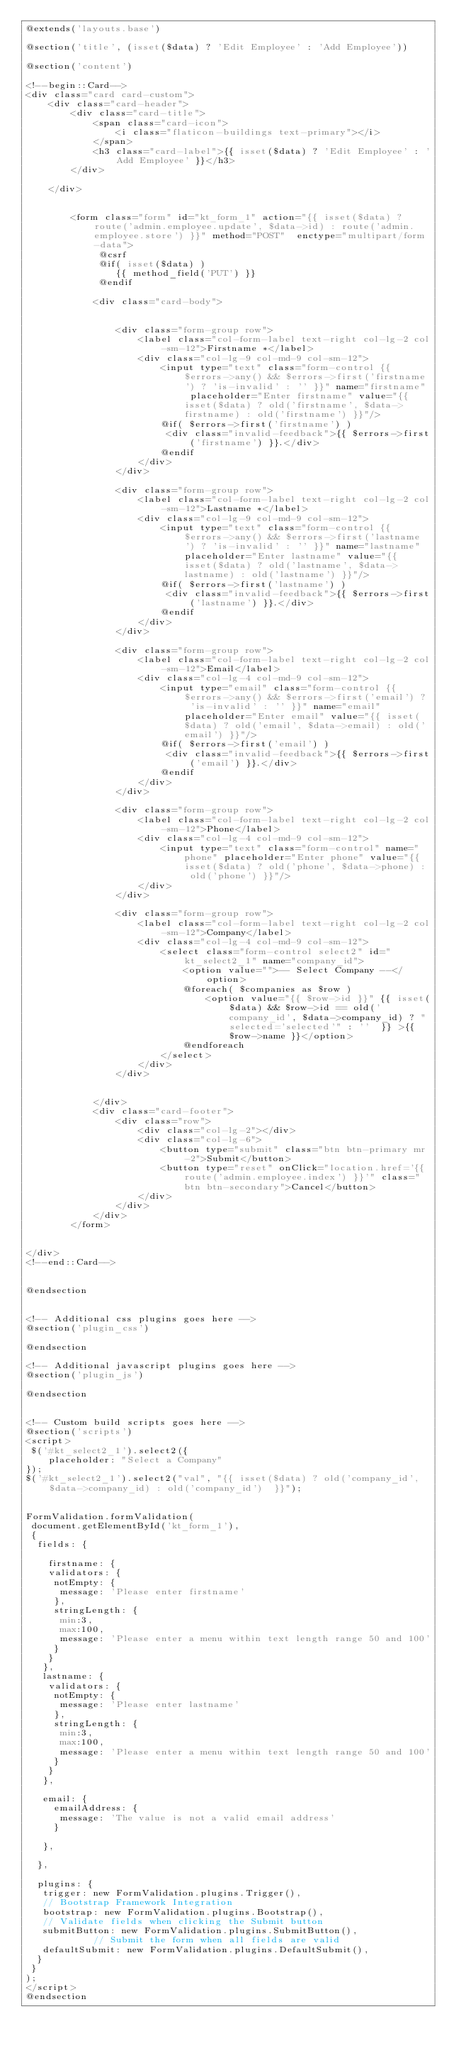<code> <loc_0><loc_0><loc_500><loc_500><_PHP_>@extends('layouts.base')

@section('title', (isset($data) ? 'Edit Employee' : 'Add Employee'))

@section('content')
    
<!--begin::Card-->
<div class="card card-custom">
    <div class="card-header">
        <div class="card-title">
            <span class="card-icon">
                <i class="flaticon-buildings text-primary"></i>
            </span>
            <h3 class="card-label">{{ isset($data) ? 'Edit Employee' : 'Add Employee' }}</h3>
        </div>

    </div>


        <form class="form" id="kt_form_1" action="{{ isset($data) ?  route('admin.employee.update', $data->id) : route('admin.employee.store') }}" method="POST"  enctype="multipart/form-data">
             @csrf
             @if( isset($data) )
                {{ method_field('PUT') }}
             @endif

            <div class="card-body">


                <div class="form-group row">
                    <label class="col-form-label text-right col-lg-2 col-sm-12">Firstname *</label>
                    <div class="col-lg-9 col-md-9 col-sm-12">
                        <input type="text" class="form-control {{ $errors->any() && $errors->first('firstname') ? 'is-invalid' : '' }}" name="firstname" placeholder="Enter firstname" value="{{ isset($data) ? old('firstname', $data->firstname) : old('firstname') }}"/>
                        @if( $errors->first('firstname') )
                         <div class="invalid-feedback">{{ $errors->first('firstname') }}.</div>
                        @endif
                    </div>
                </div>

                <div class="form-group row">
                    <label class="col-form-label text-right col-lg-2 col-sm-12">Lastname *</label>
                    <div class="col-lg-9 col-md-9 col-sm-12">
                        <input type="text" class="form-control {{ $errors->any() && $errors->first('lastname') ? 'is-invalid' : '' }}" name="lastname" placeholder="Enter lastname" value="{{ isset($data) ? old('lastname', $data->lastname) : old('lastname') }}"/>
                        @if( $errors->first('lastname') )
                         <div class="invalid-feedback">{{ $errors->first('lastname') }}.</div>
                        @endif
                    </div>
                </div>

                <div class="form-group row">
                    <label class="col-form-label text-right col-lg-2 col-sm-12">Email</label>
                    <div class="col-lg-4 col-md-9 col-sm-12">
                        <input type="email" class="form-control {{ $errors->any() && $errors->first('email') ? 'is-invalid' : '' }}" name="email" placeholder="Enter email" value="{{ isset($data) ? old('email', $data->email) : old('email') }}"/>
                        @if( $errors->first('email') )
                         <div class="invalid-feedback">{{ $errors->first('email') }}.</div>
                        @endif
                    </div>
                </div>

                <div class="form-group row">
                    <label class="col-form-label text-right col-lg-2 col-sm-12">Phone</label>
                    <div class="col-lg-4 col-md-9 col-sm-12">
                        <input type="text" class="form-control" name="phone" placeholder="Enter phone" value="{{ isset($data) ? old('phone', $data->phone) : old('phone') }}"/>
                    </div>
                </div>
                
                <div class="form-group row">
                    <label class="col-form-label text-right col-lg-2 col-sm-12">Company</label>
                    <div class="col-lg-4 col-md-9 col-sm-12">
                        <select class="form-control select2" id="kt_select2_1" name="company_id">
                            <option value="">-- Select Company --</option>
                            @foreach( $companies as $row )
                                <option value="{{ $row->id }}" {{ isset($data) && $row->id == old('company_id', $data->company_id) ? "selected='selected'" : ''  }} >{{ $row->name }}</option>
                            @endforeach
                        </select>
                    </div>
                </div>

        
            </div>
            <div class="card-footer">
                <div class="row">
                    <div class="col-lg-2"></div>
                    <div class="col-lg-6">
                        <button type="submit" class="btn btn-primary mr-2">Submit</button>
                        <button type="reset" onClick="location.href='{{ route('admin.employee.index') }}'" class="btn btn-secondary">Cancel</button>
                    </div>
                </div>
            </div>
        </form>

    
</div>
<!--end::Card-->


@endsection


<!-- Additional css plugins goes here -->
@section('plugin_css')

@endsection

<!-- Additional javascript plugins goes here -->
@section('plugin_js')

@endsection


<!-- Custom build scripts goes here -->
@section('scripts')
<script>
 $('#kt_select2_1').select2({
    placeholder: "Select a Company"
});
$('#kt_select2_1').select2("val", "{{ isset($data) ? old('company_id', $data->company_id) : old('company_id')  }}");


FormValidation.formValidation(
 document.getElementById('kt_form_1'),
 {
  fields: {

    firstname: {
    validators: {
     notEmpty: {
      message: 'Please enter firstname'
     },
     stringLength: {
      min:3,
      max:100,
      message: 'Please enter a menu within text length range 50 and 100'
     }
    }
   },
   lastname: {
    validators: {
     notEmpty: {
      message: 'Please enter lastname'
     },
     stringLength: {
      min:3,
      max:100,
      message: 'Please enter a menu within text length range 50 and 100'
     }
    }
   },

   email: {
     emailAddress: {
      message: 'The value is not a valid email address'
     }
   
   },

  },

  plugins: {
   trigger: new FormValidation.plugins.Trigger(),
   // Bootstrap Framework Integration
   bootstrap: new FormValidation.plugins.Bootstrap(),
   // Validate fields when clicking the Submit button
   submitButton: new FormValidation.plugins.SubmitButton(),
            // Submit the form when all fields are valid
   defaultSubmit: new FormValidation.plugins.DefaultSubmit(),
  }
 }
);
</script>
@endsection</code> 